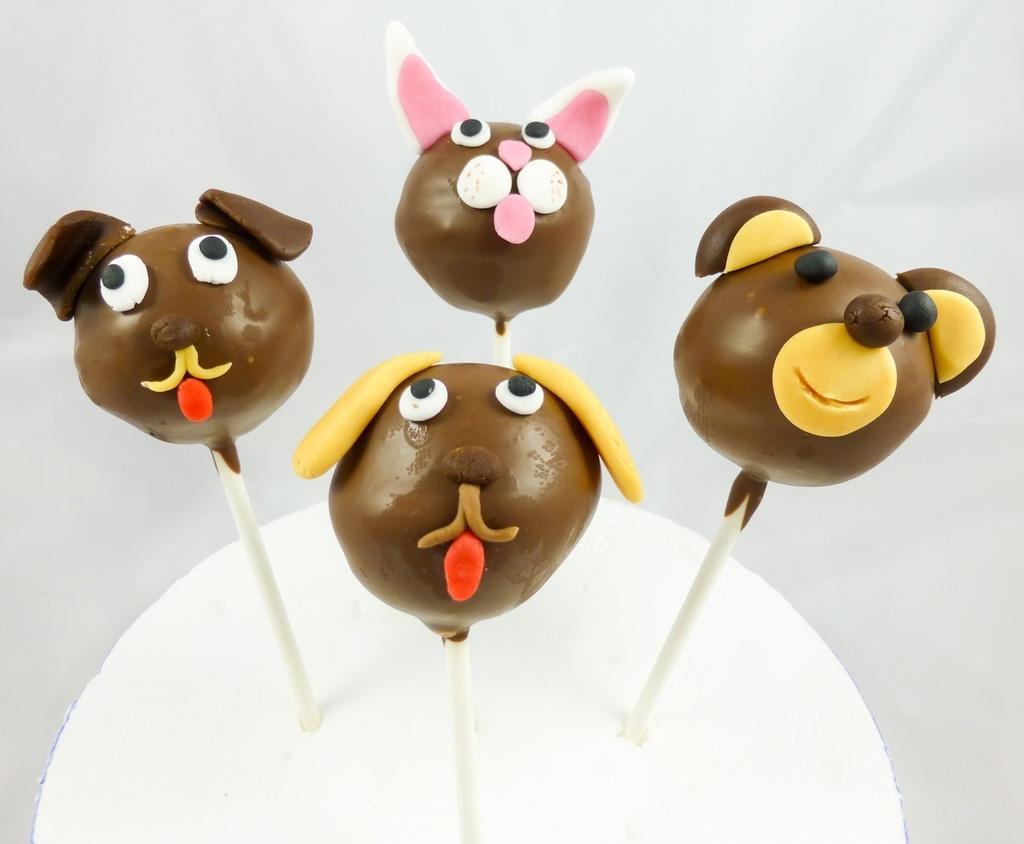In one or two sentences, can you explain what this image depicts? In this image we can see four lollipops on an object, and the background is white in color. 